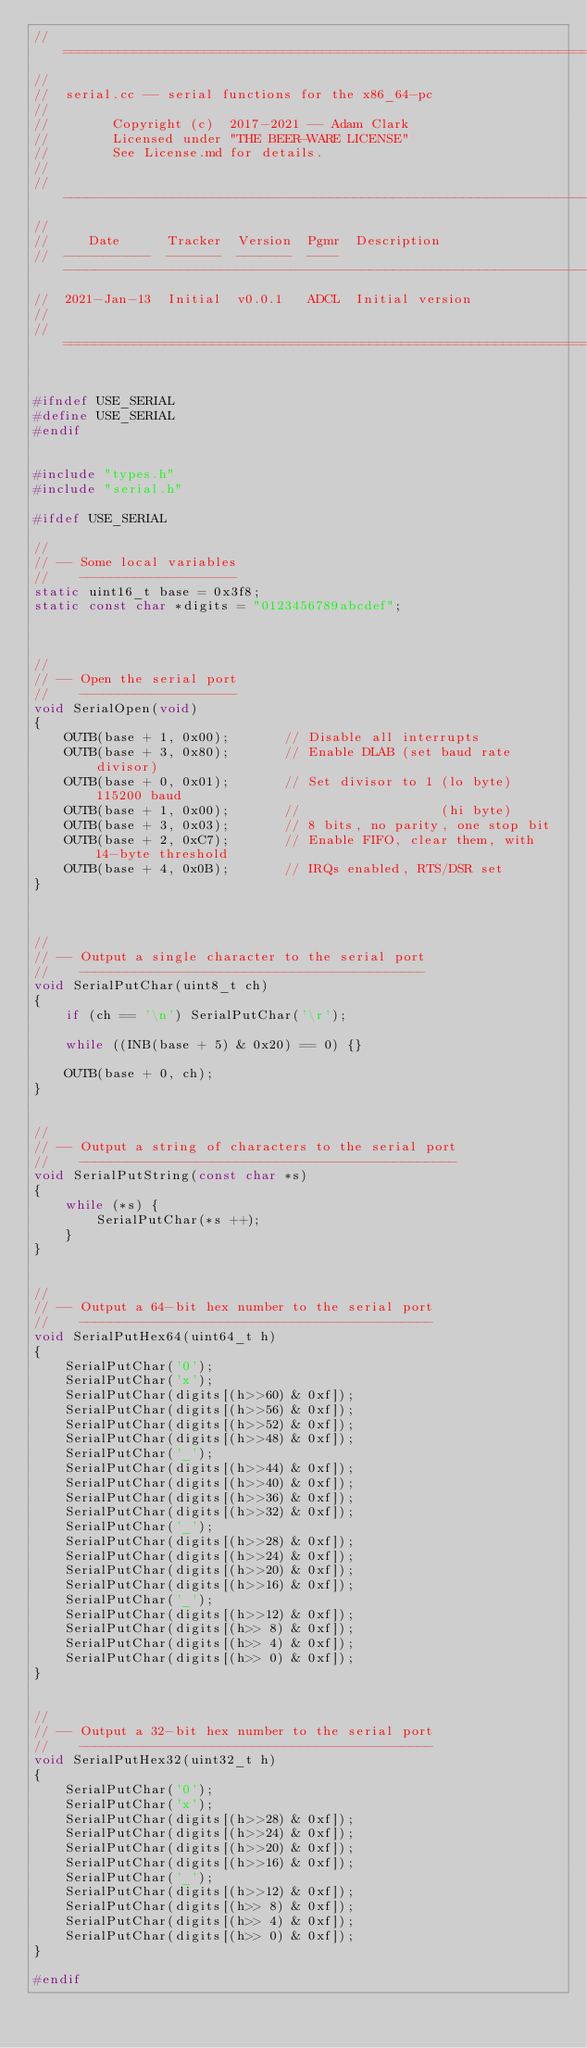<code> <loc_0><loc_0><loc_500><loc_500><_C++_>//===================================================================================================================
//
//  serial.cc -- serial functions for the x86_64-pc
//
//        Copyright (c)  2017-2021 -- Adam Clark
//        Licensed under "THE BEER-WARE LICENSE"
//        See License.md for details.
//
// ------------------------------------------------------------------------------------------------------------------
//
//     Date      Tracker  Version  Pgmr  Description
//  -----------  -------  -------  ----  ---------------------------------------------------------------------------
//  2021-Jan-13  Initial  v0.0.1   ADCL  Initial version
//
//===================================================================================================================


#ifndef USE_SERIAL
#define USE_SERIAL
#endif


#include "types.h"
#include "serial.h"

#ifdef USE_SERIAL

//
// -- Some local variables
//    --------------------
static uint16_t base = 0x3f8;
static const char *digits = "0123456789abcdef";



//
// -- Open the serial port
//    --------------------
void SerialOpen(void)
{
    OUTB(base + 1, 0x00);       // Disable all interrupts
    OUTB(base + 3, 0x80);       // Enable DLAB (set baud rate divisor)
    OUTB(base + 0, 0x01);       // Set divisor to 1 (lo byte) 115200 baud
    OUTB(base + 1, 0x00);       //                  (hi byte)
    OUTB(base + 3, 0x03);       // 8 bits, no parity, one stop bit
    OUTB(base + 2, 0xC7);       // Enable FIFO, clear them, with 14-byte threshold
    OUTB(base + 4, 0x0B);       // IRQs enabled, RTS/DSR set
}



//
// -- Output a single character to the serial port
//    --------------------------------------------
void SerialPutChar(uint8_t ch)
{
    if (ch == '\n') SerialPutChar('\r');

    while ((INB(base + 5) & 0x20) == 0) {}

    OUTB(base + 0, ch);
}


//
// -- Output a string of characters to the serial port
//    ------------------------------------------------
void SerialPutString(const char *s)
{
    while (*s) {
        SerialPutChar(*s ++);
    }
}


//
// -- Output a 64-bit hex number to the serial port
//    ---------------------------------------------
void SerialPutHex64(uint64_t h)
{
    SerialPutChar('0');
    SerialPutChar('x');
    SerialPutChar(digits[(h>>60) & 0xf]);
    SerialPutChar(digits[(h>>56) & 0xf]);
    SerialPutChar(digits[(h>>52) & 0xf]);
    SerialPutChar(digits[(h>>48) & 0xf]);
    SerialPutChar('_');
    SerialPutChar(digits[(h>>44) & 0xf]);
    SerialPutChar(digits[(h>>40) & 0xf]);
    SerialPutChar(digits[(h>>36) & 0xf]);
    SerialPutChar(digits[(h>>32) & 0xf]);
    SerialPutChar('_');
    SerialPutChar(digits[(h>>28) & 0xf]);
    SerialPutChar(digits[(h>>24) & 0xf]);
    SerialPutChar(digits[(h>>20) & 0xf]);
    SerialPutChar(digits[(h>>16) & 0xf]);
    SerialPutChar('_');
    SerialPutChar(digits[(h>>12) & 0xf]);
    SerialPutChar(digits[(h>> 8) & 0xf]);
    SerialPutChar(digits[(h>> 4) & 0xf]);
    SerialPutChar(digits[(h>> 0) & 0xf]);
}


//
// -- Output a 32-bit hex number to the serial port
//    ---------------------------------------------
void SerialPutHex32(uint32_t h)
{
    SerialPutChar('0');
    SerialPutChar('x');
    SerialPutChar(digits[(h>>28) & 0xf]);
    SerialPutChar(digits[(h>>24) & 0xf]);
    SerialPutChar(digits[(h>>20) & 0xf]);
    SerialPutChar(digits[(h>>16) & 0xf]);
    SerialPutChar('_');
    SerialPutChar(digits[(h>>12) & 0xf]);
    SerialPutChar(digits[(h>> 8) & 0xf]);
    SerialPutChar(digits[(h>> 4) & 0xf]);
    SerialPutChar(digits[(h>> 0) & 0xf]);
}

#endif
</code> 